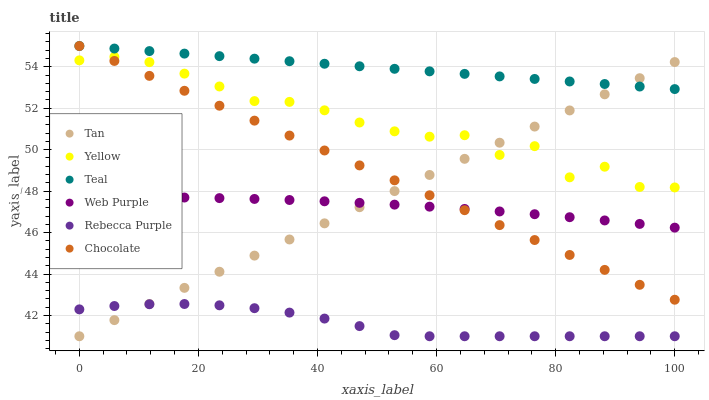Does Rebecca Purple have the minimum area under the curve?
Answer yes or no. Yes. Does Teal have the maximum area under the curve?
Answer yes or no. Yes. Does Chocolate have the minimum area under the curve?
Answer yes or no. No. Does Chocolate have the maximum area under the curve?
Answer yes or no. No. Is Tan the smoothest?
Answer yes or no. Yes. Is Yellow the roughest?
Answer yes or no. Yes. Is Chocolate the smoothest?
Answer yes or no. No. Is Chocolate the roughest?
Answer yes or no. No. Does Rebecca Purple have the lowest value?
Answer yes or no. Yes. Does Chocolate have the lowest value?
Answer yes or no. No. Does Teal have the highest value?
Answer yes or no. Yes. Does Web Purple have the highest value?
Answer yes or no. No. Is Rebecca Purple less than Yellow?
Answer yes or no. Yes. Is Teal greater than Yellow?
Answer yes or no. Yes. Does Tan intersect Rebecca Purple?
Answer yes or no. Yes. Is Tan less than Rebecca Purple?
Answer yes or no. No. Is Tan greater than Rebecca Purple?
Answer yes or no. No. Does Rebecca Purple intersect Yellow?
Answer yes or no. No. 